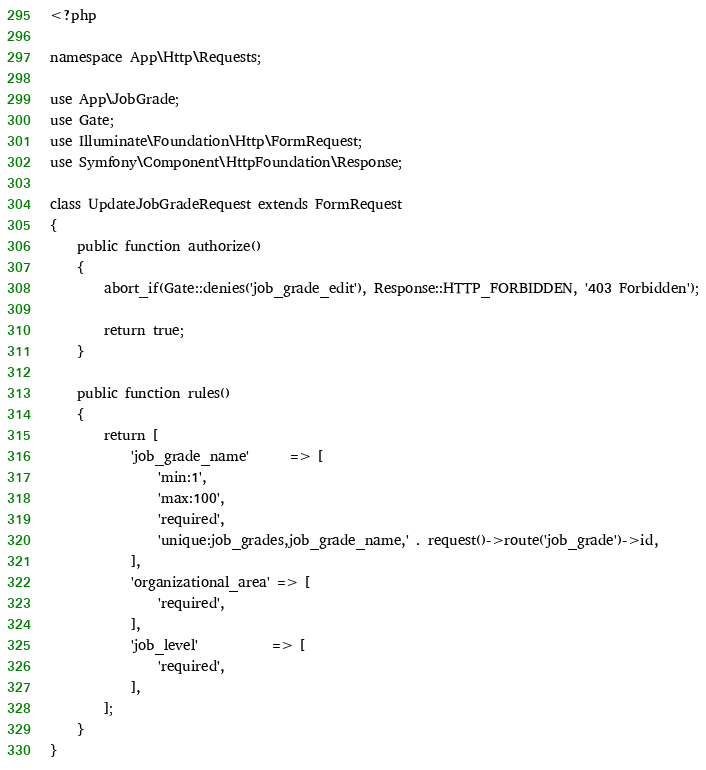Convert code to text. <code><loc_0><loc_0><loc_500><loc_500><_PHP_><?php

namespace App\Http\Requests;

use App\JobGrade;
use Gate;
use Illuminate\Foundation\Http\FormRequest;
use Symfony\Component\HttpFoundation\Response;

class UpdateJobGradeRequest extends FormRequest
{
    public function authorize()
    {
        abort_if(Gate::denies('job_grade_edit'), Response::HTTP_FORBIDDEN, '403 Forbidden');

        return true;
    }

    public function rules()
    {
        return [
            'job_grade_name'      => [
                'min:1',
                'max:100',
                'required',
                'unique:job_grades,job_grade_name,' . request()->route('job_grade')->id,
            ],
            'organizational_area' => [
                'required',
            ],
            'job_level'           => [
                'required',
            ],
        ];
    }
}
</code> 